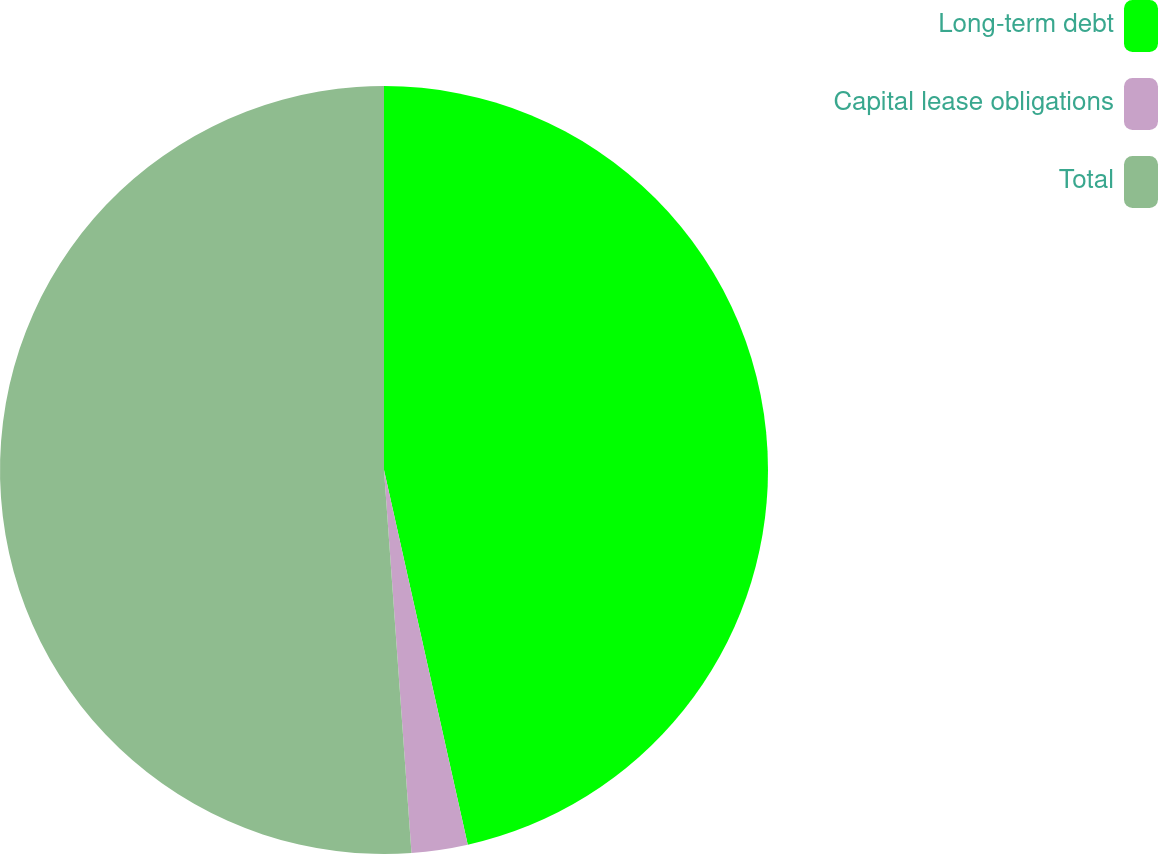Convert chart to OTSL. <chart><loc_0><loc_0><loc_500><loc_500><pie_chart><fcel>Long-term debt<fcel>Capital lease obligations<fcel>Total<nl><fcel>46.5%<fcel>2.36%<fcel>51.14%<nl></chart> 